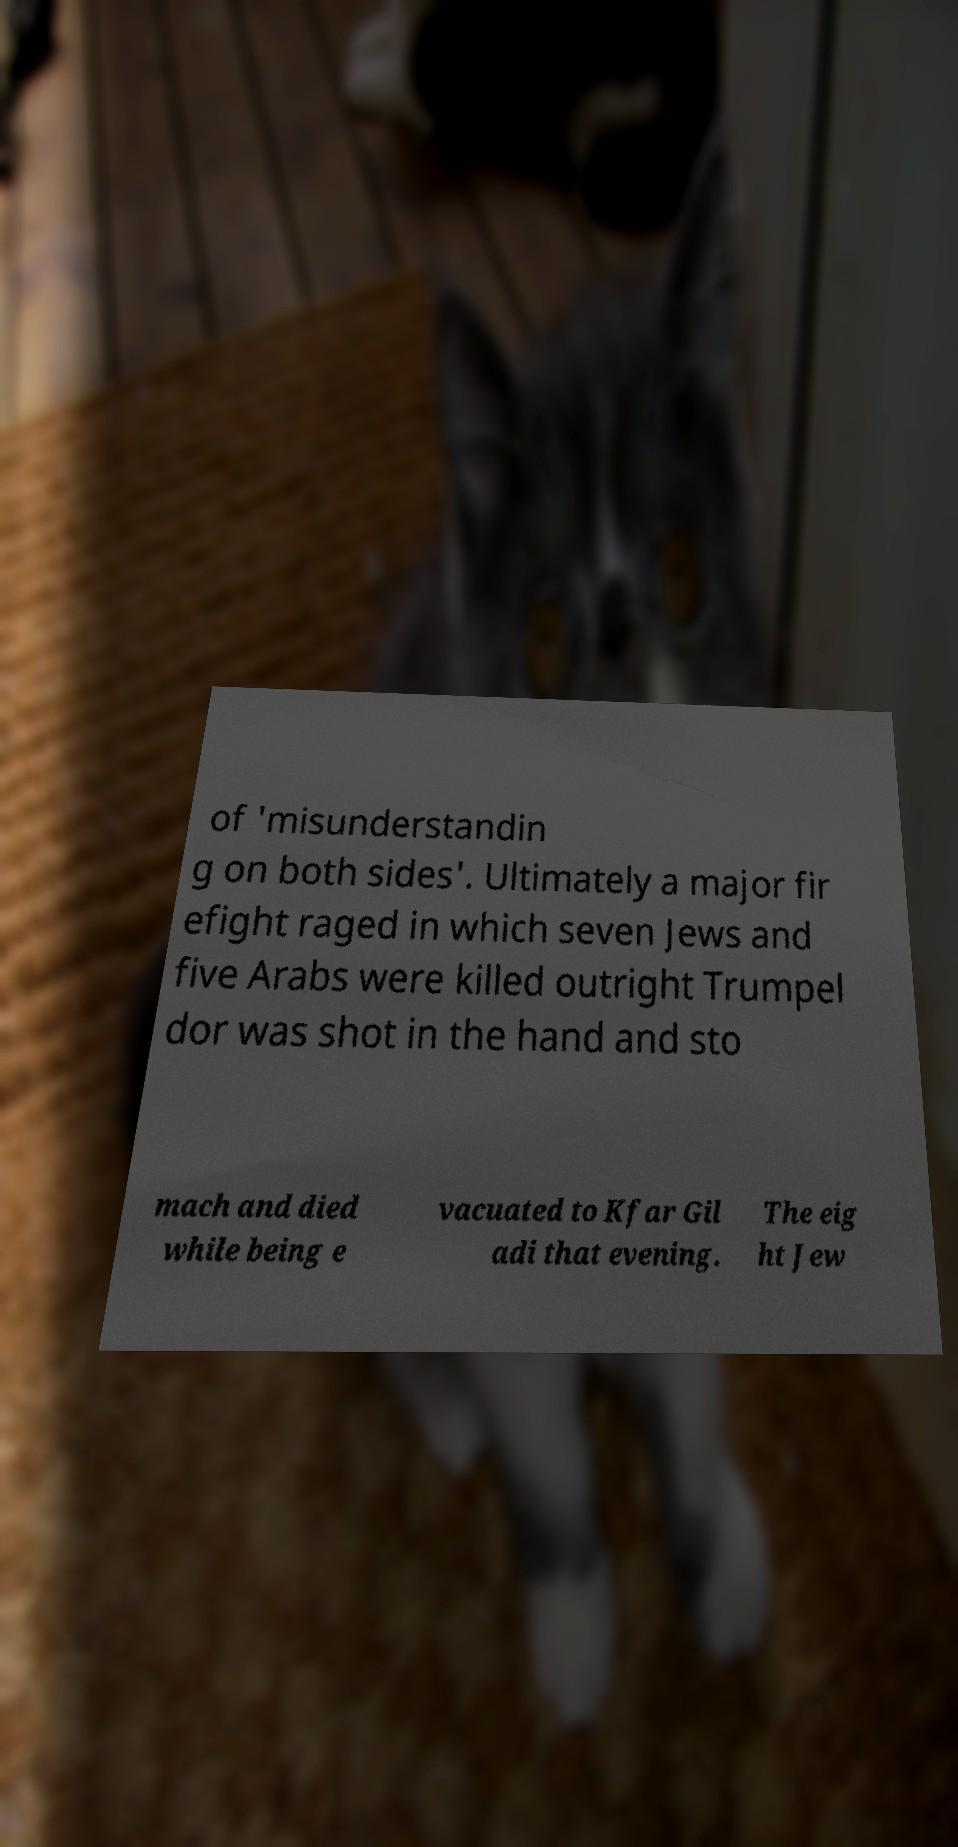I need the written content from this picture converted into text. Can you do that? of 'misunderstandin g on both sides'. Ultimately a major fir efight raged in which seven Jews and five Arabs were killed outright Trumpel dor was shot in the hand and sto mach and died while being e vacuated to Kfar Gil adi that evening. The eig ht Jew 